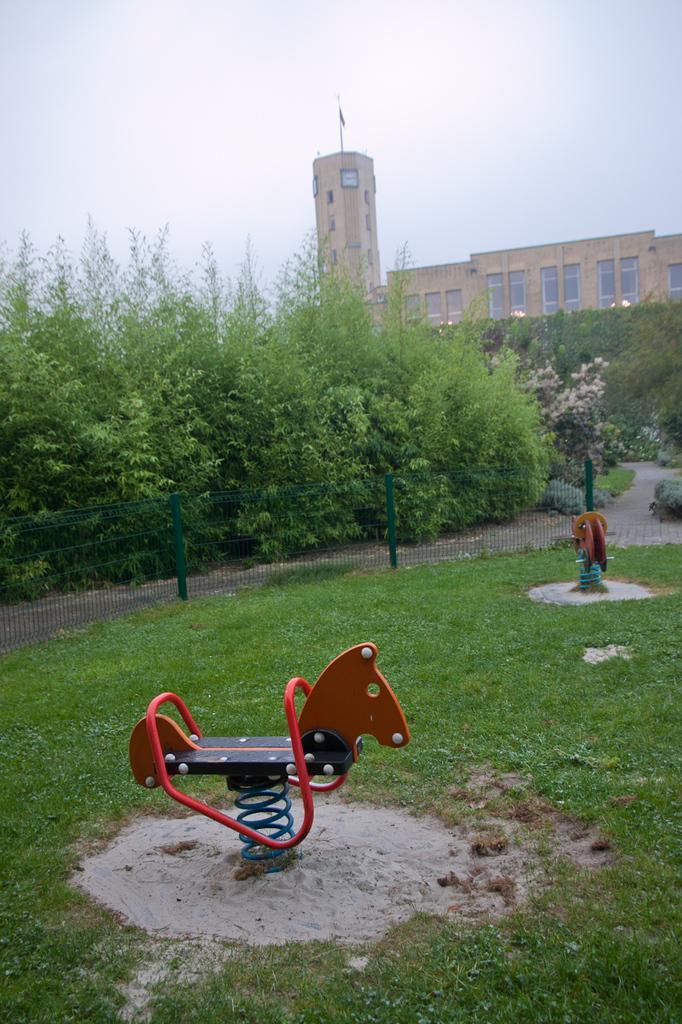Please provide a concise description of this image. The picture might be taken in a playground. In the foreground there are playthings, sand and grass. In the center of the picture there are trees and flowers. In the background there is a building, on the top of the building there is a flag. At the top sky. 